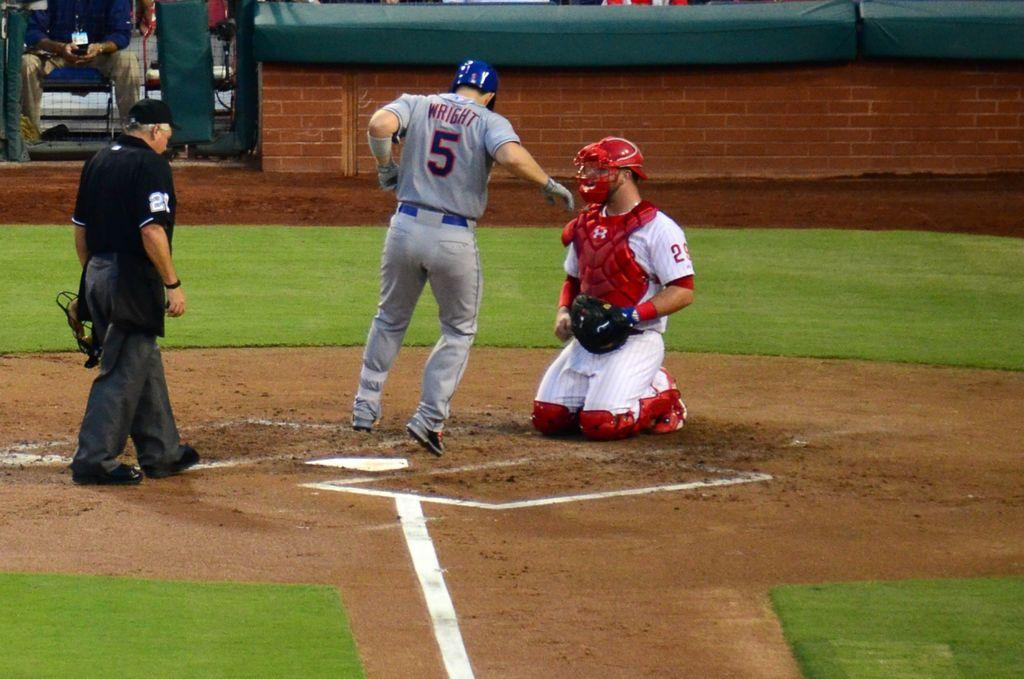<image>
Share a concise interpretation of the image provided. A baseball player with the name Wright and the number 5 on the back of his Jersey is facing the opposite direction of the field, toward the umpire. 